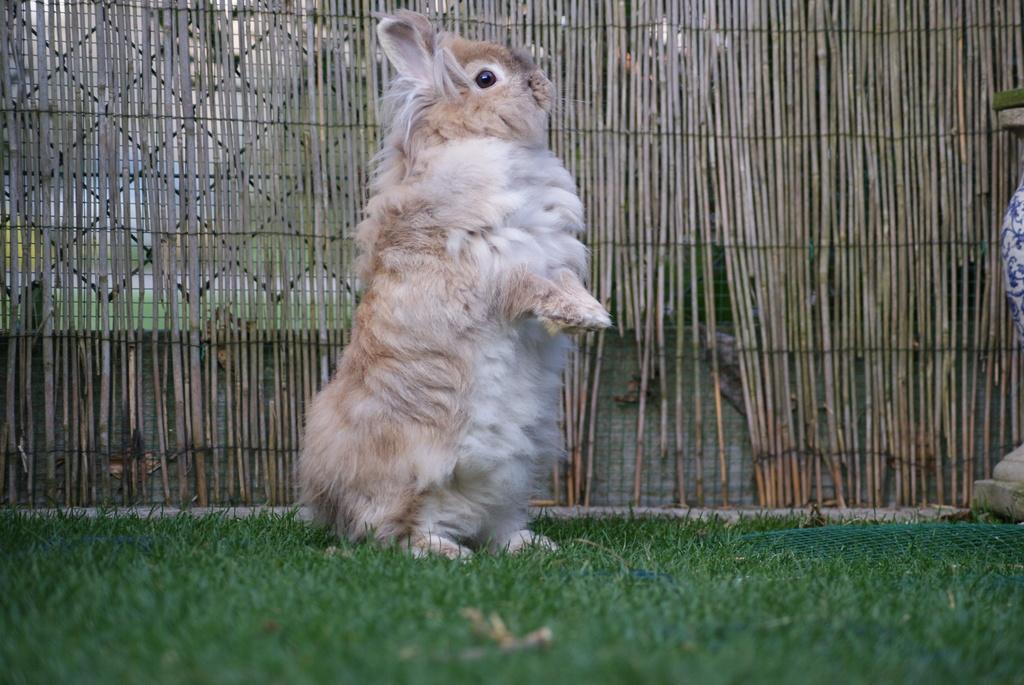Describe this image in one or two sentences. In this image there is an animal on the grass, the grass is truncated towards the bottom of the image, there is an object on the grass, there is an object truncated towards the right of the image, at the background of the image there is a fencing truncated. 